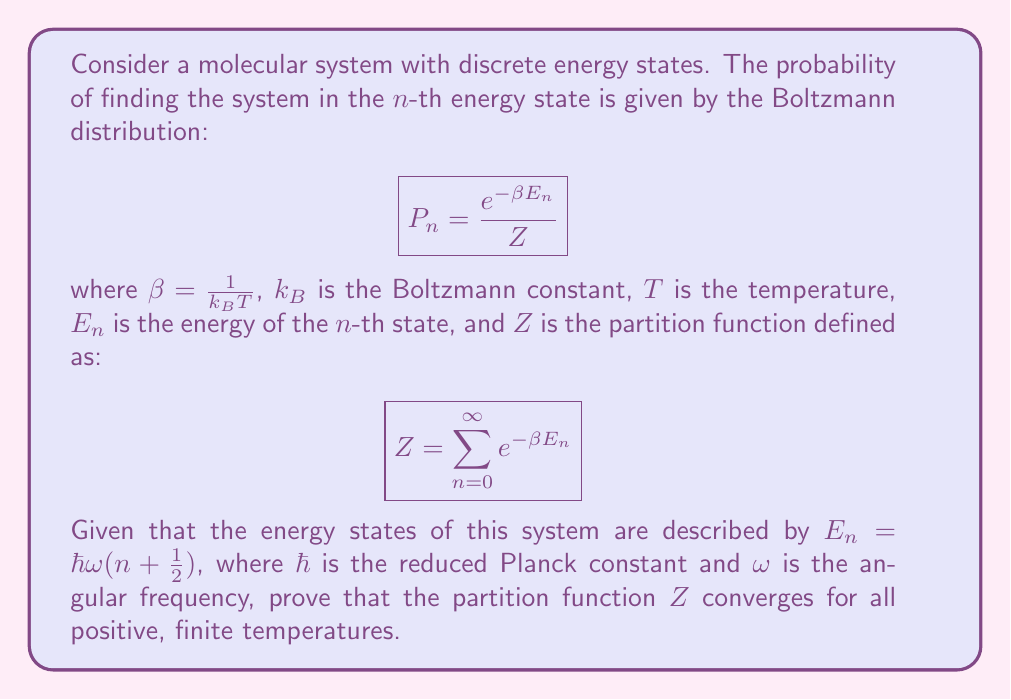Help me with this question. To prove the convergence of the partition function $Z$, we need to show that the series $\sum_{n=0}^{\infty} e^{-\beta E_n}$ converges. Let's approach this step-by-step:

1) First, let's substitute the given expression for $E_n$ into the partition function:

   $$Z = \sum_{n=0}^{\infty} e^{-\beta \hbar \omega (n + \frac{1}{2})}$$

2) We can factor out the constant terms:

   $$Z = e^{-\beta \hbar \omega / 2} \sum_{n=0}^{\infty} e^{-\beta \hbar \omega n}$$

3) Let's define $q = e^{-\beta \hbar \omega}$. Then we can rewrite the series as:

   $$Z = e^{-\beta \hbar \omega / 2} \sum_{n=0}^{\infty} q^n$$

4) We recognize this as a geometric series with first term $a=1$ and common ratio $r=q$. For a geometric series to converge, we need $|r| < 1$.

5) In our case, $|r| = |q| = |e^{-\beta \hbar \omega}| = e^{-\beta \hbar \omega}$ (since $\beta, \hbar, \omega$ are all positive real numbers).

6) For any positive, finite temperature $T$, we have:
   
   $\beta = \frac{1}{k_B T} > 0$
   $\hbar > 0$
   $\omega > 0$

   Therefore, $\beta \hbar \omega > 0$, which means $e^{-\beta \hbar \omega} < 1$.

7) Since $|r| = e^{-\beta \hbar \omega} < 1$, the geometric series converges.

8) The sum of a convergent geometric series with $|r| < 1$ is given by $\frac{1}{1-r}$. Therefore:

   $$Z = e^{-\beta \hbar \omega / 2} \frac{1}{1-e^{-\beta \hbar \omega}}$$

Thus, we have proven that the partition function $Z$ converges for all positive, finite temperatures, and we have found its closed-form expression.
Answer: The partition function $Z$ converges for all positive, finite temperatures, and its closed-form expression is:

$$Z = \frac{e^{-\beta \hbar \omega / 2}}{1-e^{-\beta \hbar \omega}}$$

where $\beta = \frac{1}{k_B T}$, $k_B$ is the Boltzmann constant, $T$ is the temperature, $\hbar$ is the reduced Planck constant, and $\omega$ is the angular frequency of the system. 